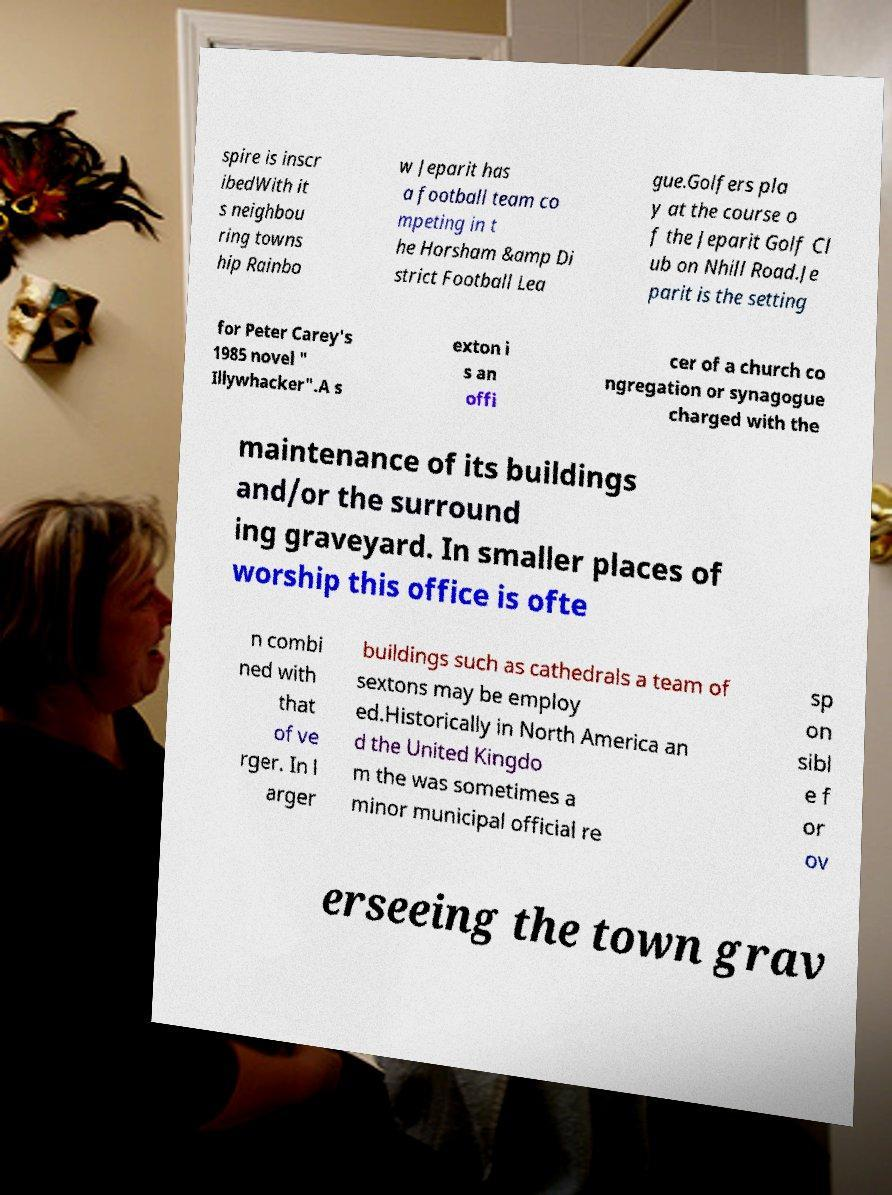Can you read and provide the text displayed in the image?This photo seems to have some interesting text. Can you extract and type it out for me? spire is inscr ibedWith it s neighbou ring towns hip Rainbo w Jeparit has a football team co mpeting in t he Horsham &amp Di strict Football Lea gue.Golfers pla y at the course o f the Jeparit Golf Cl ub on Nhill Road.Je parit is the setting for Peter Carey's 1985 novel " Illywhacker".A s exton i s an offi cer of a church co ngregation or synagogue charged with the maintenance of its buildings and/or the surround ing graveyard. In smaller places of worship this office is ofte n combi ned with that of ve rger. In l arger buildings such as cathedrals a team of sextons may be employ ed.Historically in North America an d the United Kingdo m the was sometimes a minor municipal official re sp on sibl e f or ov erseeing the town grav 